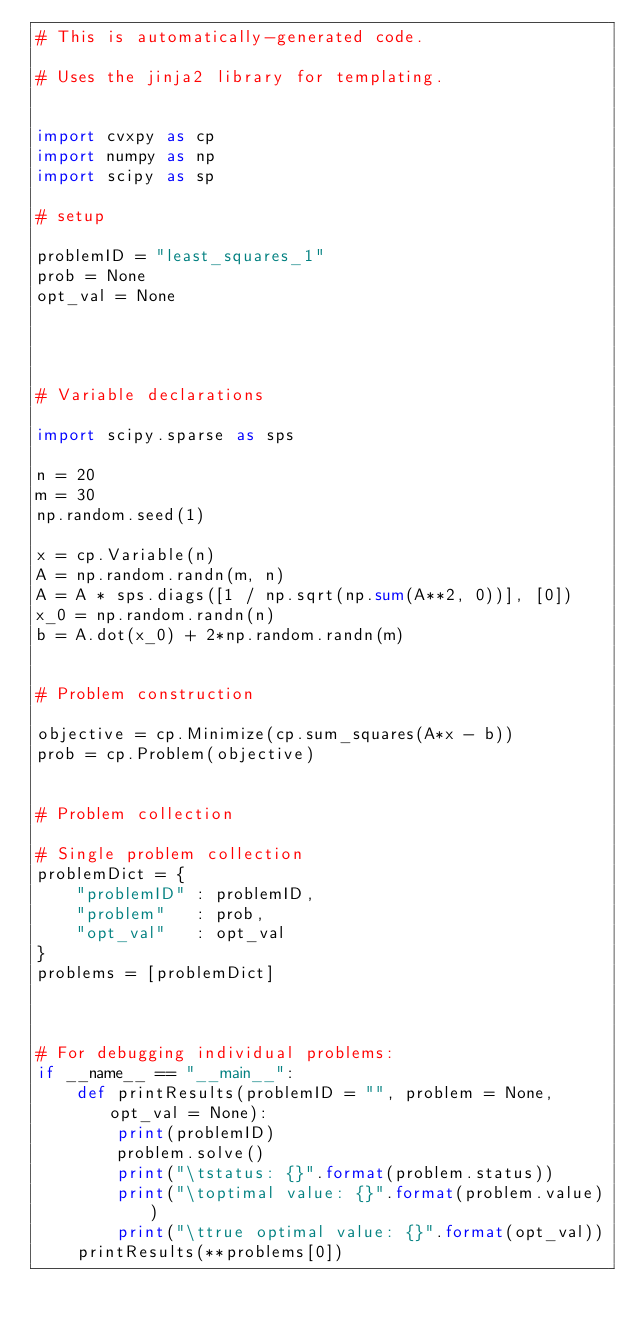Convert code to text. <code><loc_0><loc_0><loc_500><loc_500><_Python_># This is automatically-generated code.

# Uses the jinja2 library for templating.


import cvxpy as cp
import numpy as np
import scipy as sp

# setup

problemID = "least_squares_1"
prob = None
opt_val = None




# Variable declarations

import scipy.sparse as sps

n = 20
m = 30
np.random.seed(1)

x = cp.Variable(n)
A = np.random.randn(m, n)
A = A * sps.diags([1 / np.sqrt(np.sum(A**2, 0))], [0])
x_0 = np.random.randn(n)
b = A.dot(x_0) + 2*np.random.randn(m)


# Problem construction

objective = cp.Minimize(cp.sum_squares(A*x - b))
prob = cp.Problem(objective)


# Problem collection

# Single problem collection
problemDict = {
    "problemID" : problemID,
    "problem"   : prob,
    "opt_val"   : opt_val
}
problems = [problemDict]



# For debugging individual problems:
if __name__ == "__main__":
    def printResults(problemID = "", problem = None, opt_val = None):
        print(problemID)
        problem.solve()
        print("\tstatus: {}".format(problem.status))
        print("\toptimal value: {}".format(problem.value))
        print("\ttrue optimal value: {}".format(opt_val))
    printResults(**problems[0])


</code> 